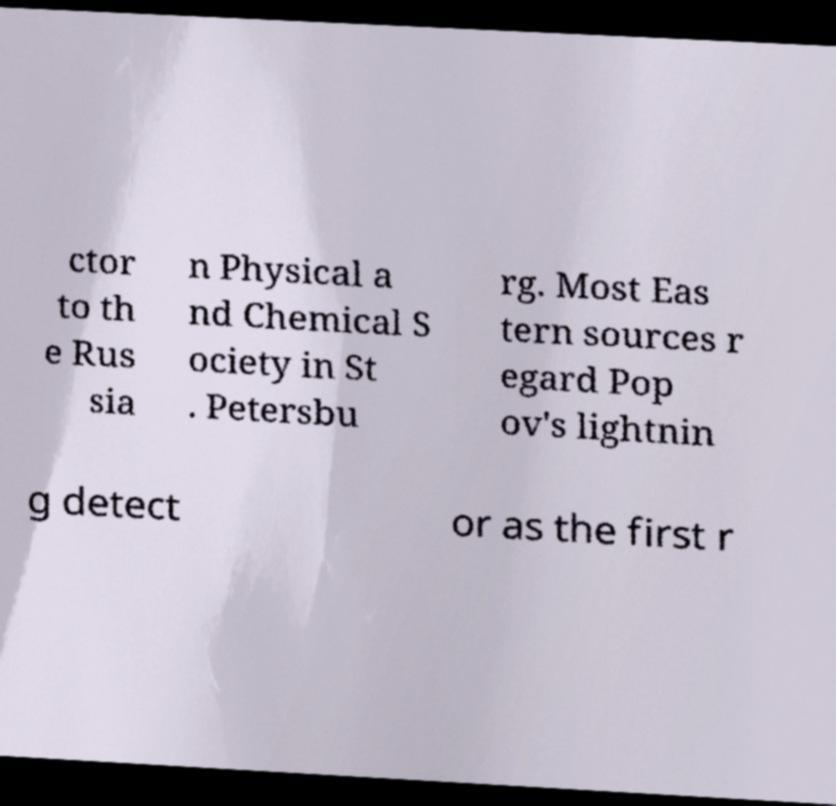Please identify and transcribe the text found in this image. ctor to th e Rus sia n Physical a nd Chemical S ociety in St . Petersbu rg. Most Eas tern sources r egard Pop ov's lightnin g detect or as the first r 